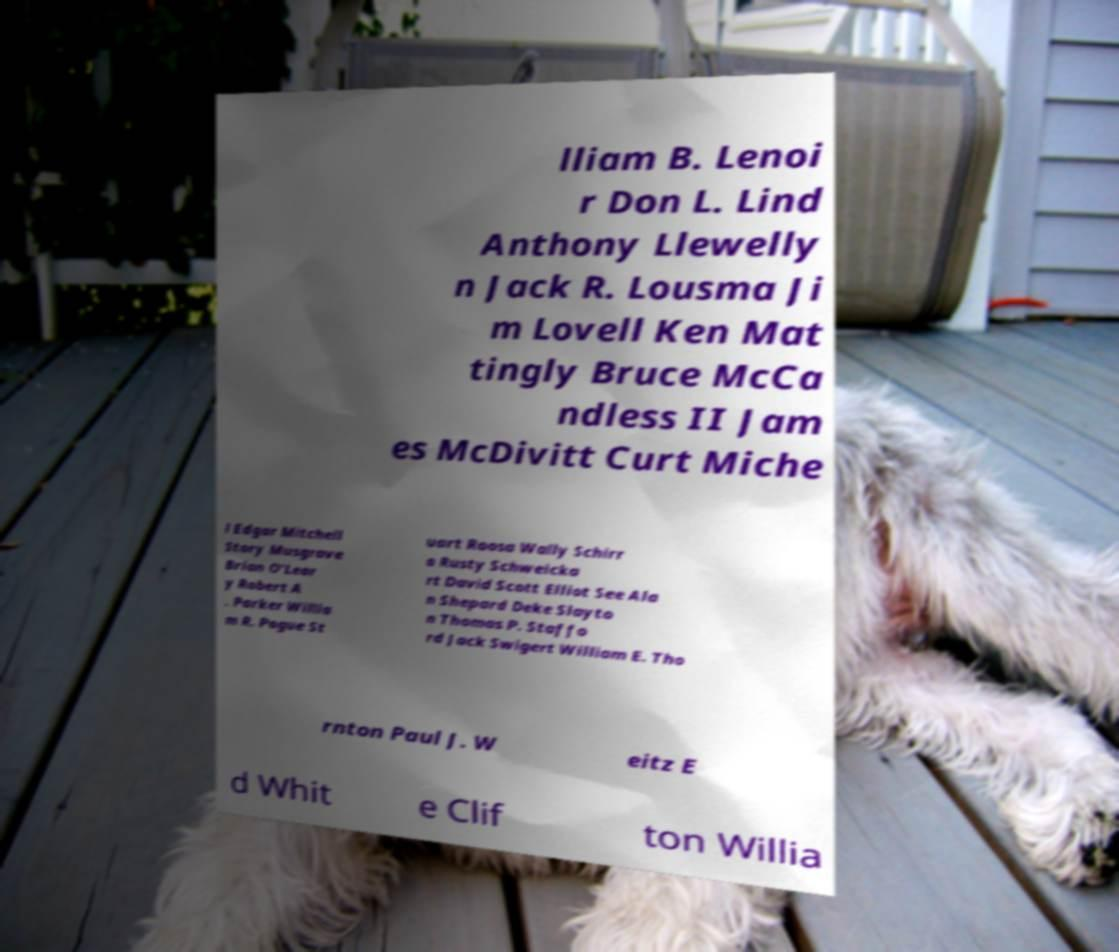Could you extract and type out the text from this image? lliam B. Lenoi r Don L. Lind Anthony Llewelly n Jack R. Lousma Ji m Lovell Ken Mat tingly Bruce McCa ndless II Jam es McDivitt Curt Miche l Edgar Mitchell Story Musgrave Brian O'Lear y Robert A . Parker Willia m R. Pogue St uart Roosa Wally Schirr a Rusty Schweicka rt David Scott Elliot See Ala n Shepard Deke Slayto n Thomas P. Staffo rd Jack Swigert William E. Tho rnton Paul J. W eitz E d Whit e Clif ton Willia 